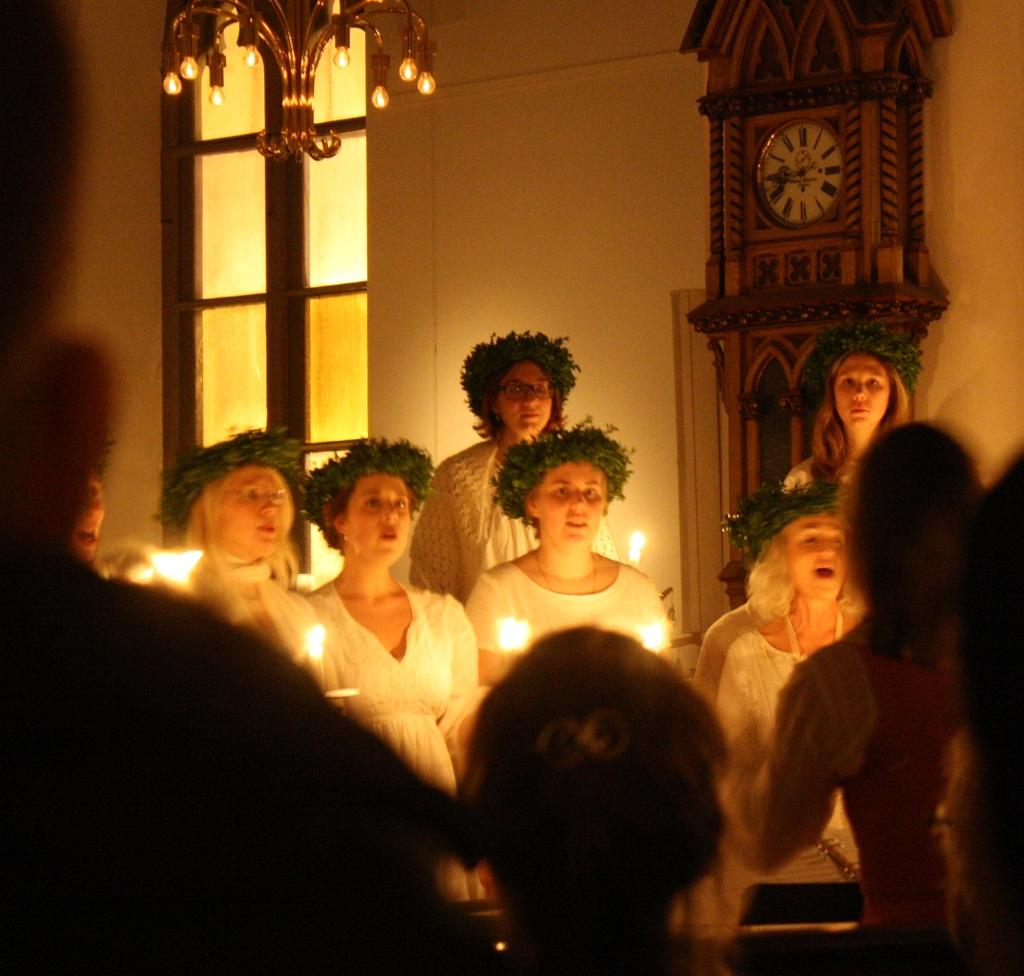Who or what can be seen in the image? There are people in the image. What objects related to light are present in the image? There are candles and lights in the image. What architectural feature is visible in the image? There is a window in the image. What time-related object is present in the image? There is a clock in the image. What type of surface is present in the image? There is a wall in the image. How much money does the porter charge in the image? There is no porter present in the image, so it is not possible to determine the amount charged. 